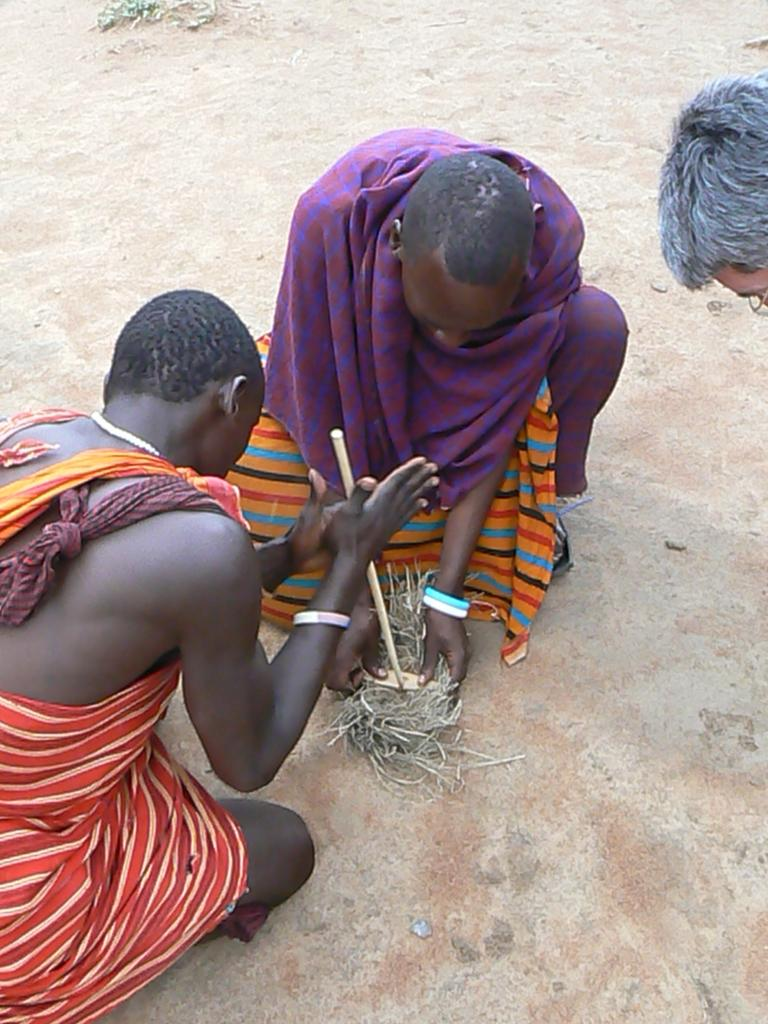What are the two people in the image doing? The two people in the image are laying on their knees on the ground. What are the objects they are holding in their hands? The two people are holding objects in their hands, but the specific objects are not mentioned in the facts. What is the third person doing in the image? There is a person bending beside them. What type of coat is the boy wearing in the image? There is no boy or coat mentioned in the facts, so we cannot answer this question based on the provided information. 